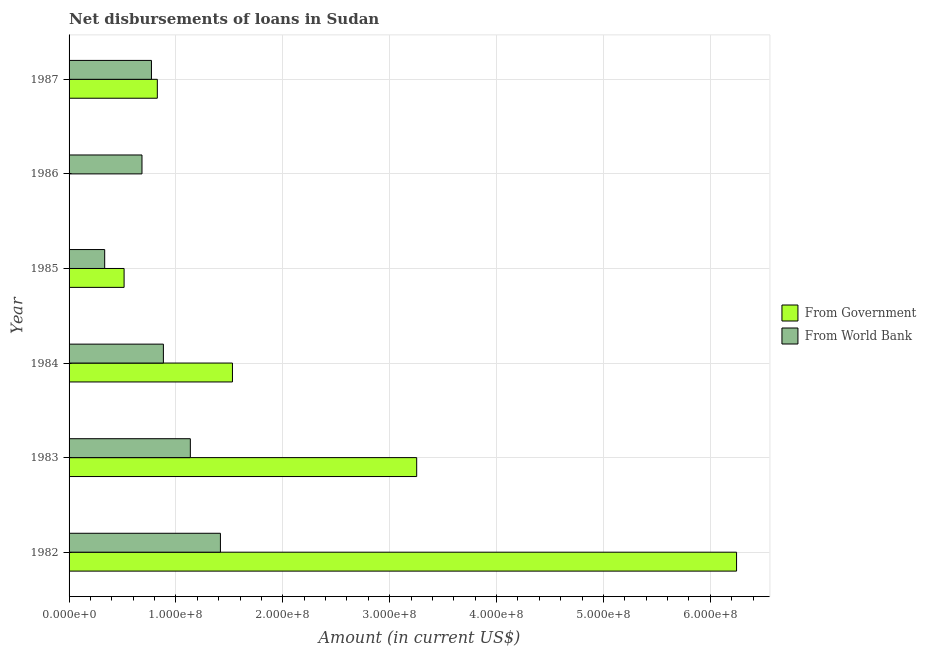How many different coloured bars are there?
Provide a succinct answer. 2. Are the number of bars per tick equal to the number of legend labels?
Your answer should be compact. No. How many bars are there on the 3rd tick from the top?
Your response must be concise. 2. What is the label of the 4th group of bars from the top?
Give a very brief answer. 1984. In how many cases, is the number of bars for a given year not equal to the number of legend labels?
Make the answer very short. 1. What is the net disbursements of loan from government in 1983?
Your response must be concise. 3.25e+08. Across all years, what is the maximum net disbursements of loan from world bank?
Your answer should be compact. 1.42e+08. Across all years, what is the minimum net disbursements of loan from world bank?
Your answer should be compact. 3.33e+07. What is the total net disbursements of loan from government in the graph?
Offer a terse response. 1.24e+09. What is the difference between the net disbursements of loan from world bank in 1984 and that in 1986?
Offer a very short reply. 2.00e+07. What is the difference between the net disbursements of loan from government in 1987 and the net disbursements of loan from world bank in 1985?
Offer a very short reply. 4.93e+07. What is the average net disbursements of loan from government per year?
Ensure brevity in your answer.  2.06e+08. In the year 1983, what is the difference between the net disbursements of loan from world bank and net disbursements of loan from government?
Give a very brief answer. -2.12e+08. What is the ratio of the net disbursements of loan from world bank in 1984 to that in 1987?
Your answer should be very brief. 1.15. Is the net disbursements of loan from world bank in 1983 less than that in 1987?
Your response must be concise. No. What is the difference between the highest and the second highest net disbursements of loan from government?
Offer a terse response. 2.99e+08. What is the difference between the highest and the lowest net disbursements of loan from world bank?
Offer a very short reply. 1.08e+08. In how many years, is the net disbursements of loan from government greater than the average net disbursements of loan from government taken over all years?
Your answer should be very brief. 2. Is the sum of the net disbursements of loan from world bank in 1983 and 1985 greater than the maximum net disbursements of loan from government across all years?
Your answer should be very brief. No. How many years are there in the graph?
Ensure brevity in your answer.  6. Does the graph contain grids?
Provide a succinct answer. Yes. Where does the legend appear in the graph?
Offer a very short reply. Center right. What is the title of the graph?
Offer a very short reply. Net disbursements of loans in Sudan. Does "Birth rate" appear as one of the legend labels in the graph?
Keep it short and to the point. No. What is the label or title of the X-axis?
Your response must be concise. Amount (in current US$). What is the label or title of the Y-axis?
Offer a very short reply. Year. What is the Amount (in current US$) in From Government in 1982?
Offer a very short reply. 6.25e+08. What is the Amount (in current US$) of From World Bank in 1982?
Your answer should be compact. 1.42e+08. What is the Amount (in current US$) in From Government in 1983?
Offer a very short reply. 3.25e+08. What is the Amount (in current US$) in From World Bank in 1983?
Ensure brevity in your answer.  1.13e+08. What is the Amount (in current US$) of From Government in 1984?
Give a very brief answer. 1.53e+08. What is the Amount (in current US$) in From World Bank in 1984?
Offer a terse response. 8.83e+07. What is the Amount (in current US$) of From Government in 1985?
Provide a short and direct response. 5.15e+07. What is the Amount (in current US$) in From World Bank in 1985?
Provide a succinct answer. 3.33e+07. What is the Amount (in current US$) of From Government in 1986?
Offer a very short reply. 0. What is the Amount (in current US$) in From World Bank in 1986?
Ensure brevity in your answer.  6.82e+07. What is the Amount (in current US$) in From Government in 1987?
Give a very brief answer. 8.26e+07. What is the Amount (in current US$) of From World Bank in 1987?
Your response must be concise. 7.71e+07. Across all years, what is the maximum Amount (in current US$) in From Government?
Give a very brief answer. 6.25e+08. Across all years, what is the maximum Amount (in current US$) of From World Bank?
Your response must be concise. 1.42e+08. Across all years, what is the minimum Amount (in current US$) of From World Bank?
Ensure brevity in your answer.  3.33e+07. What is the total Amount (in current US$) of From Government in the graph?
Make the answer very short. 1.24e+09. What is the total Amount (in current US$) of From World Bank in the graph?
Provide a succinct answer. 5.22e+08. What is the difference between the Amount (in current US$) in From Government in 1982 and that in 1983?
Keep it short and to the point. 2.99e+08. What is the difference between the Amount (in current US$) in From World Bank in 1982 and that in 1983?
Provide a short and direct response. 2.82e+07. What is the difference between the Amount (in current US$) of From Government in 1982 and that in 1984?
Make the answer very short. 4.72e+08. What is the difference between the Amount (in current US$) in From World Bank in 1982 and that in 1984?
Provide a short and direct response. 5.34e+07. What is the difference between the Amount (in current US$) in From Government in 1982 and that in 1985?
Offer a terse response. 5.73e+08. What is the difference between the Amount (in current US$) in From World Bank in 1982 and that in 1985?
Provide a short and direct response. 1.08e+08. What is the difference between the Amount (in current US$) in From World Bank in 1982 and that in 1986?
Offer a very short reply. 7.34e+07. What is the difference between the Amount (in current US$) of From Government in 1982 and that in 1987?
Your answer should be very brief. 5.42e+08. What is the difference between the Amount (in current US$) in From World Bank in 1982 and that in 1987?
Provide a short and direct response. 6.45e+07. What is the difference between the Amount (in current US$) of From Government in 1983 and that in 1984?
Provide a succinct answer. 1.72e+08. What is the difference between the Amount (in current US$) of From World Bank in 1983 and that in 1984?
Provide a short and direct response. 2.52e+07. What is the difference between the Amount (in current US$) of From Government in 1983 and that in 1985?
Keep it short and to the point. 2.74e+08. What is the difference between the Amount (in current US$) in From World Bank in 1983 and that in 1985?
Your response must be concise. 8.02e+07. What is the difference between the Amount (in current US$) of From World Bank in 1983 and that in 1986?
Offer a very short reply. 4.52e+07. What is the difference between the Amount (in current US$) of From Government in 1983 and that in 1987?
Your answer should be very brief. 2.43e+08. What is the difference between the Amount (in current US$) in From World Bank in 1983 and that in 1987?
Ensure brevity in your answer.  3.64e+07. What is the difference between the Amount (in current US$) of From Government in 1984 and that in 1985?
Your response must be concise. 1.01e+08. What is the difference between the Amount (in current US$) of From World Bank in 1984 and that in 1985?
Provide a short and direct response. 5.49e+07. What is the difference between the Amount (in current US$) of From World Bank in 1984 and that in 1986?
Provide a succinct answer. 2.00e+07. What is the difference between the Amount (in current US$) in From Government in 1984 and that in 1987?
Ensure brevity in your answer.  7.03e+07. What is the difference between the Amount (in current US$) in From World Bank in 1984 and that in 1987?
Keep it short and to the point. 1.12e+07. What is the difference between the Amount (in current US$) in From World Bank in 1985 and that in 1986?
Your answer should be very brief. -3.49e+07. What is the difference between the Amount (in current US$) of From Government in 1985 and that in 1987?
Your answer should be very brief. -3.11e+07. What is the difference between the Amount (in current US$) in From World Bank in 1985 and that in 1987?
Your response must be concise. -4.38e+07. What is the difference between the Amount (in current US$) of From World Bank in 1986 and that in 1987?
Make the answer very short. -8.86e+06. What is the difference between the Amount (in current US$) in From Government in 1982 and the Amount (in current US$) in From World Bank in 1983?
Keep it short and to the point. 5.11e+08. What is the difference between the Amount (in current US$) in From Government in 1982 and the Amount (in current US$) in From World Bank in 1984?
Give a very brief answer. 5.36e+08. What is the difference between the Amount (in current US$) of From Government in 1982 and the Amount (in current US$) of From World Bank in 1985?
Offer a very short reply. 5.91e+08. What is the difference between the Amount (in current US$) in From Government in 1982 and the Amount (in current US$) in From World Bank in 1986?
Give a very brief answer. 5.56e+08. What is the difference between the Amount (in current US$) of From Government in 1982 and the Amount (in current US$) of From World Bank in 1987?
Provide a succinct answer. 5.48e+08. What is the difference between the Amount (in current US$) of From Government in 1983 and the Amount (in current US$) of From World Bank in 1984?
Give a very brief answer. 2.37e+08. What is the difference between the Amount (in current US$) in From Government in 1983 and the Amount (in current US$) in From World Bank in 1985?
Offer a very short reply. 2.92e+08. What is the difference between the Amount (in current US$) in From Government in 1983 and the Amount (in current US$) in From World Bank in 1986?
Your answer should be compact. 2.57e+08. What is the difference between the Amount (in current US$) of From Government in 1983 and the Amount (in current US$) of From World Bank in 1987?
Ensure brevity in your answer.  2.48e+08. What is the difference between the Amount (in current US$) of From Government in 1984 and the Amount (in current US$) of From World Bank in 1985?
Offer a very short reply. 1.20e+08. What is the difference between the Amount (in current US$) in From Government in 1984 and the Amount (in current US$) in From World Bank in 1986?
Offer a very short reply. 8.47e+07. What is the difference between the Amount (in current US$) of From Government in 1984 and the Amount (in current US$) of From World Bank in 1987?
Provide a succinct answer. 7.58e+07. What is the difference between the Amount (in current US$) in From Government in 1985 and the Amount (in current US$) in From World Bank in 1986?
Give a very brief answer. -1.67e+07. What is the difference between the Amount (in current US$) in From Government in 1985 and the Amount (in current US$) in From World Bank in 1987?
Give a very brief answer. -2.56e+07. What is the average Amount (in current US$) of From Government per year?
Make the answer very short. 2.06e+08. What is the average Amount (in current US$) of From World Bank per year?
Give a very brief answer. 8.70e+07. In the year 1982, what is the difference between the Amount (in current US$) of From Government and Amount (in current US$) of From World Bank?
Make the answer very short. 4.83e+08. In the year 1983, what is the difference between the Amount (in current US$) in From Government and Amount (in current US$) in From World Bank?
Provide a short and direct response. 2.12e+08. In the year 1984, what is the difference between the Amount (in current US$) of From Government and Amount (in current US$) of From World Bank?
Ensure brevity in your answer.  6.46e+07. In the year 1985, what is the difference between the Amount (in current US$) of From Government and Amount (in current US$) of From World Bank?
Offer a terse response. 1.82e+07. In the year 1987, what is the difference between the Amount (in current US$) of From Government and Amount (in current US$) of From World Bank?
Your response must be concise. 5.51e+06. What is the ratio of the Amount (in current US$) of From Government in 1982 to that in 1983?
Make the answer very short. 1.92. What is the ratio of the Amount (in current US$) of From World Bank in 1982 to that in 1983?
Give a very brief answer. 1.25. What is the ratio of the Amount (in current US$) in From Government in 1982 to that in 1984?
Provide a short and direct response. 4.09. What is the ratio of the Amount (in current US$) in From World Bank in 1982 to that in 1984?
Your response must be concise. 1.6. What is the ratio of the Amount (in current US$) of From Government in 1982 to that in 1985?
Give a very brief answer. 12.13. What is the ratio of the Amount (in current US$) of From World Bank in 1982 to that in 1985?
Make the answer very short. 4.25. What is the ratio of the Amount (in current US$) in From World Bank in 1982 to that in 1986?
Offer a terse response. 2.08. What is the ratio of the Amount (in current US$) of From Government in 1982 to that in 1987?
Your response must be concise. 7.56. What is the ratio of the Amount (in current US$) in From World Bank in 1982 to that in 1987?
Provide a succinct answer. 1.84. What is the ratio of the Amount (in current US$) of From Government in 1983 to that in 1984?
Your answer should be very brief. 2.13. What is the ratio of the Amount (in current US$) in From World Bank in 1983 to that in 1984?
Make the answer very short. 1.29. What is the ratio of the Amount (in current US$) in From Government in 1983 to that in 1985?
Provide a succinct answer. 6.32. What is the ratio of the Amount (in current US$) in From World Bank in 1983 to that in 1985?
Provide a short and direct response. 3.41. What is the ratio of the Amount (in current US$) in From World Bank in 1983 to that in 1986?
Ensure brevity in your answer.  1.66. What is the ratio of the Amount (in current US$) of From Government in 1983 to that in 1987?
Give a very brief answer. 3.94. What is the ratio of the Amount (in current US$) of From World Bank in 1983 to that in 1987?
Provide a succinct answer. 1.47. What is the ratio of the Amount (in current US$) in From Government in 1984 to that in 1985?
Your answer should be very brief. 2.97. What is the ratio of the Amount (in current US$) of From World Bank in 1984 to that in 1985?
Offer a terse response. 2.65. What is the ratio of the Amount (in current US$) in From World Bank in 1984 to that in 1986?
Give a very brief answer. 1.29. What is the ratio of the Amount (in current US$) in From Government in 1984 to that in 1987?
Your response must be concise. 1.85. What is the ratio of the Amount (in current US$) in From World Bank in 1984 to that in 1987?
Give a very brief answer. 1.14. What is the ratio of the Amount (in current US$) in From World Bank in 1985 to that in 1986?
Your answer should be very brief. 0.49. What is the ratio of the Amount (in current US$) in From Government in 1985 to that in 1987?
Offer a terse response. 0.62. What is the ratio of the Amount (in current US$) in From World Bank in 1985 to that in 1987?
Provide a succinct answer. 0.43. What is the ratio of the Amount (in current US$) of From World Bank in 1986 to that in 1987?
Offer a terse response. 0.89. What is the difference between the highest and the second highest Amount (in current US$) in From Government?
Offer a terse response. 2.99e+08. What is the difference between the highest and the second highest Amount (in current US$) of From World Bank?
Give a very brief answer. 2.82e+07. What is the difference between the highest and the lowest Amount (in current US$) in From Government?
Offer a terse response. 6.25e+08. What is the difference between the highest and the lowest Amount (in current US$) of From World Bank?
Make the answer very short. 1.08e+08. 